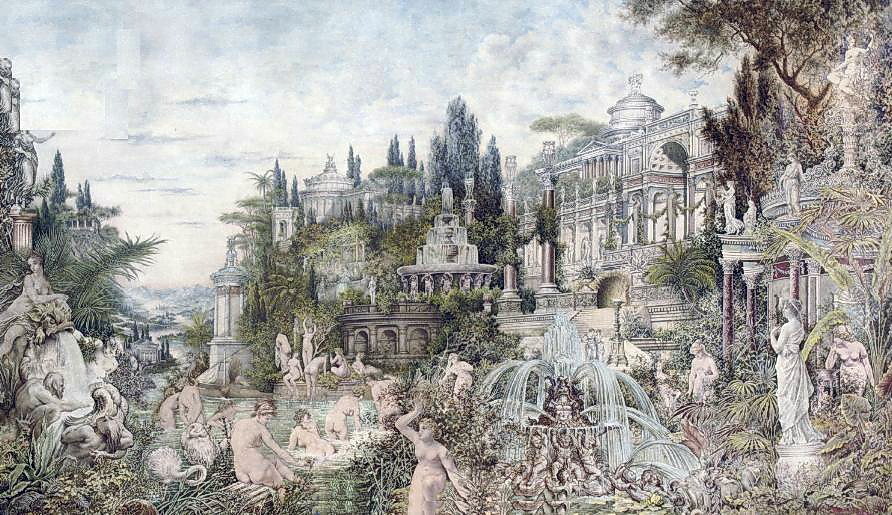What kind of flora can be observed in the gardens surrounding the palace? In the gardens surrounding the palace, a rich variety of flora can be observed. The image showcases a blend of ornamental plants and trees, contributing to the lush and vibrant atmosphere. Tall, elegant cypress trees stand guard, adding vertical interest and a sense of grandeur. Flowering shrubs and bushes, possibly roses and hydrangeas, burst with color, providing visual delight and fragrance.

Additionally, clusters of ferns and leafy plants nestle around the bases of statues and fountains, softening the stone elements with their greenery. There are also climbing vines and ivy adorning walls and pergolas, enhancing the sense of a verdant, natural haven.

The garden's diverse plant life, carefully arranged and maintained, not only enhances its aesthetic appeal but also creates a harmonious and inviting environment. How does the light in the image contribute to its overall mood? The lighting in the image plays a significant role in establishing its overall mood. Soft, diffused light pervades the scene, casting gentle shadows and highlighting the intricate details of the palace, statues, and gardens. This type of lighting enhances the serene and tranquil ambiance, lending the landscape a dreamlike quality.

The interplay of light and shadow creates depth and dimension, making the architectural and natural elements appear more vivid and lifelike. The subtle illumination of pastel hues, particularly the greens and blues, contributes to a calming atmosphere, inviting viewers to immerse themselves in the peaceful and enchanting world depicted in the image. 